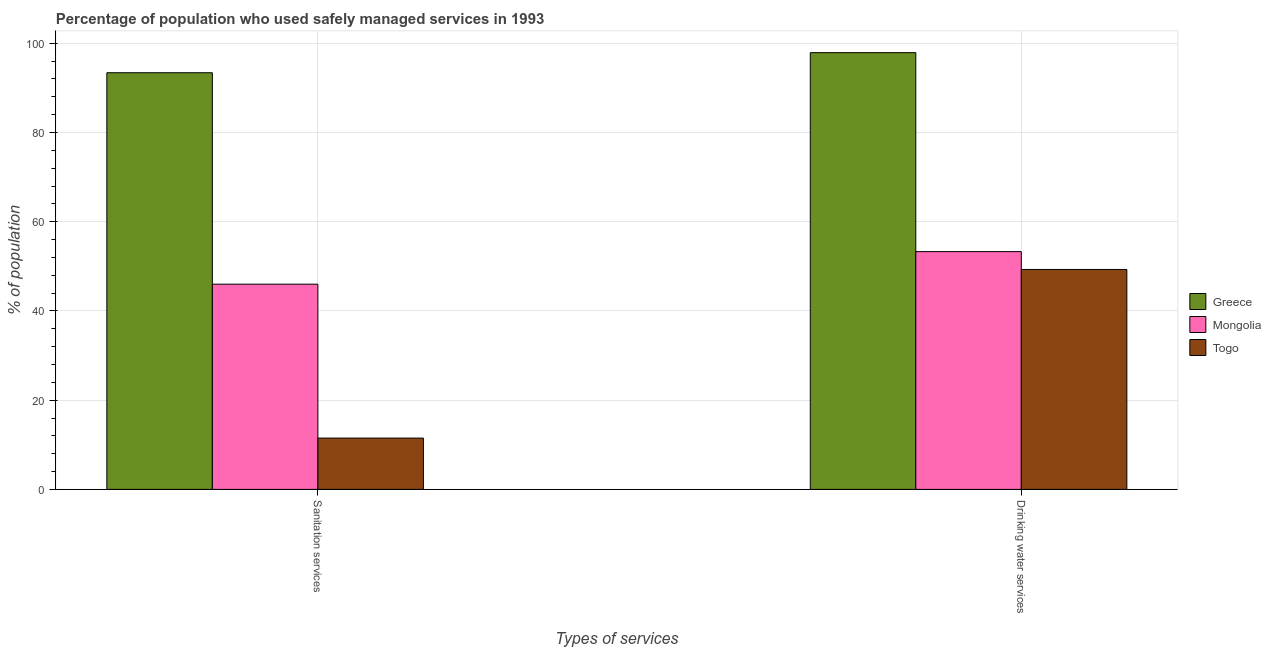How many different coloured bars are there?
Provide a succinct answer. 3. Are the number of bars on each tick of the X-axis equal?
Offer a very short reply. Yes. What is the label of the 1st group of bars from the left?
Your response must be concise. Sanitation services. What is the percentage of population who used drinking water services in Greece?
Offer a terse response. 97.9. Across all countries, what is the maximum percentage of population who used sanitation services?
Keep it short and to the point. 93.4. In which country was the percentage of population who used drinking water services maximum?
Provide a short and direct response. Greece. In which country was the percentage of population who used sanitation services minimum?
Offer a very short reply. Togo. What is the total percentage of population who used drinking water services in the graph?
Provide a short and direct response. 200.5. What is the difference between the percentage of population who used drinking water services in Togo and that in Greece?
Ensure brevity in your answer.  -48.6. What is the difference between the percentage of population who used drinking water services in Greece and the percentage of population who used sanitation services in Togo?
Your response must be concise. 86.4. What is the average percentage of population who used drinking water services per country?
Your answer should be very brief. 66.83. What is the ratio of the percentage of population who used drinking water services in Mongolia to that in Togo?
Offer a terse response. 1.08. In how many countries, is the percentage of population who used sanitation services greater than the average percentage of population who used sanitation services taken over all countries?
Provide a succinct answer. 1. What does the 1st bar from the left in Drinking water services represents?
Keep it short and to the point. Greece. What does the 1st bar from the right in Sanitation services represents?
Keep it short and to the point. Togo. How many bars are there?
Provide a succinct answer. 6. How many countries are there in the graph?
Provide a succinct answer. 3. What is the difference between two consecutive major ticks on the Y-axis?
Your answer should be very brief. 20. Are the values on the major ticks of Y-axis written in scientific E-notation?
Keep it short and to the point. No. How are the legend labels stacked?
Offer a very short reply. Vertical. What is the title of the graph?
Offer a very short reply. Percentage of population who used safely managed services in 1993. Does "Mongolia" appear as one of the legend labels in the graph?
Ensure brevity in your answer.  Yes. What is the label or title of the X-axis?
Keep it short and to the point. Types of services. What is the label or title of the Y-axis?
Your response must be concise. % of population. What is the % of population in Greece in Sanitation services?
Give a very brief answer. 93.4. What is the % of population of Greece in Drinking water services?
Ensure brevity in your answer.  97.9. What is the % of population of Mongolia in Drinking water services?
Offer a terse response. 53.3. What is the % of population of Togo in Drinking water services?
Keep it short and to the point. 49.3. Across all Types of services, what is the maximum % of population of Greece?
Give a very brief answer. 97.9. Across all Types of services, what is the maximum % of population in Mongolia?
Provide a short and direct response. 53.3. Across all Types of services, what is the maximum % of population in Togo?
Your response must be concise. 49.3. Across all Types of services, what is the minimum % of population of Greece?
Give a very brief answer. 93.4. Across all Types of services, what is the minimum % of population in Mongolia?
Give a very brief answer. 46. Across all Types of services, what is the minimum % of population of Togo?
Your answer should be compact. 11.5. What is the total % of population in Greece in the graph?
Provide a short and direct response. 191.3. What is the total % of population of Mongolia in the graph?
Provide a succinct answer. 99.3. What is the total % of population in Togo in the graph?
Offer a terse response. 60.8. What is the difference between the % of population in Togo in Sanitation services and that in Drinking water services?
Provide a succinct answer. -37.8. What is the difference between the % of population of Greece in Sanitation services and the % of population of Mongolia in Drinking water services?
Give a very brief answer. 40.1. What is the difference between the % of population of Greece in Sanitation services and the % of population of Togo in Drinking water services?
Keep it short and to the point. 44.1. What is the average % of population of Greece per Types of services?
Your response must be concise. 95.65. What is the average % of population in Mongolia per Types of services?
Provide a succinct answer. 49.65. What is the average % of population of Togo per Types of services?
Keep it short and to the point. 30.4. What is the difference between the % of population of Greece and % of population of Mongolia in Sanitation services?
Offer a terse response. 47.4. What is the difference between the % of population in Greece and % of population in Togo in Sanitation services?
Give a very brief answer. 81.9. What is the difference between the % of population of Mongolia and % of population of Togo in Sanitation services?
Offer a terse response. 34.5. What is the difference between the % of population in Greece and % of population in Mongolia in Drinking water services?
Provide a short and direct response. 44.6. What is the difference between the % of population of Greece and % of population of Togo in Drinking water services?
Provide a short and direct response. 48.6. What is the difference between the % of population in Mongolia and % of population in Togo in Drinking water services?
Give a very brief answer. 4. What is the ratio of the % of population of Greece in Sanitation services to that in Drinking water services?
Your answer should be very brief. 0.95. What is the ratio of the % of population of Mongolia in Sanitation services to that in Drinking water services?
Give a very brief answer. 0.86. What is the ratio of the % of population in Togo in Sanitation services to that in Drinking water services?
Give a very brief answer. 0.23. What is the difference between the highest and the second highest % of population in Mongolia?
Offer a very short reply. 7.3. What is the difference between the highest and the second highest % of population of Togo?
Offer a terse response. 37.8. What is the difference between the highest and the lowest % of population of Mongolia?
Your answer should be compact. 7.3. What is the difference between the highest and the lowest % of population of Togo?
Your response must be concise. 37.8. 